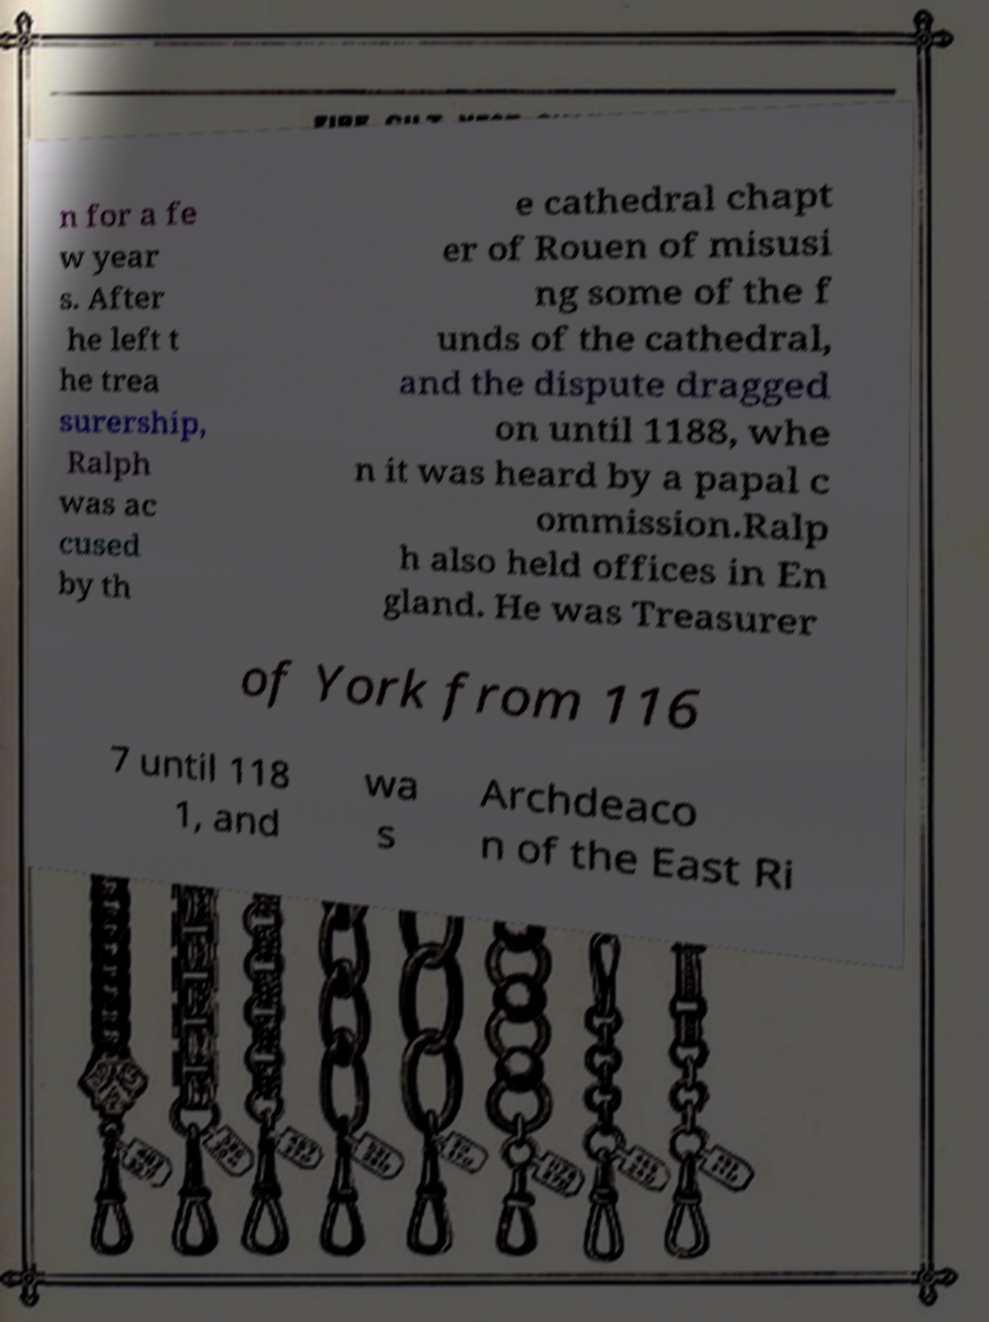Please read and relay the text visible in this image. What does it say? n for a fe w year s. After he left t he trea surership, Ralph was ac cused by th e cathedral chapt er of Rouen of misusi ng some of the f unds of the cathedral, and the dispute dragged on until 1188, whe n it was heard by a papal c ommission.Ralp h also held offices in En gland. He was Treasurer of York from 116 7 until 118 1, and wa s Archdeaco n of the East Ri 